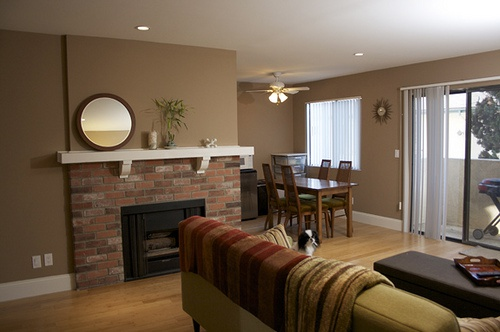Describe the objects in this image and their specific colors. I can see couch in black, maroon, and tan tones, bench in black and gray tones, chair in black, maroon, and gray tones, dining table in black, maroon, and gray tones, and potted plant in black, olive, and gray tones in this image. 